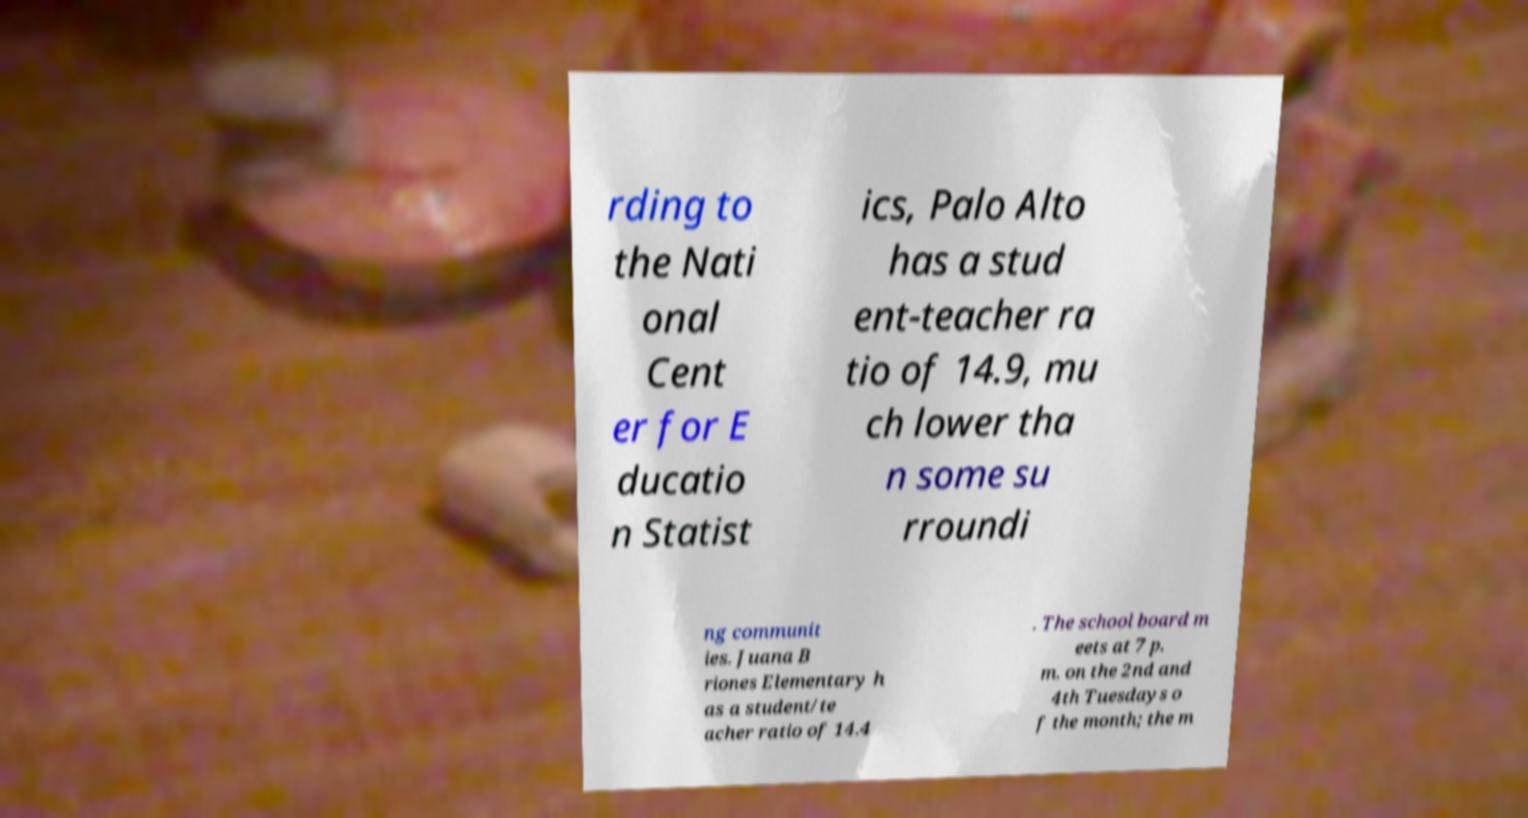For documentation purposes, I need the text within this image transcribed. Could you provide that? rding to the Nati onal Cent er for E ducatio n Statist ics, Palo Alto has a stud ent-teacher ra tio of 14.9, mu ch lower tha n some su rroundi ng communit ies. Juana B riones Elementary h as a student/te acher ratio of 14.4 . The school board m eets at 7 p. m. on the 2nd and 4th Tuesdays o f the month; the m 